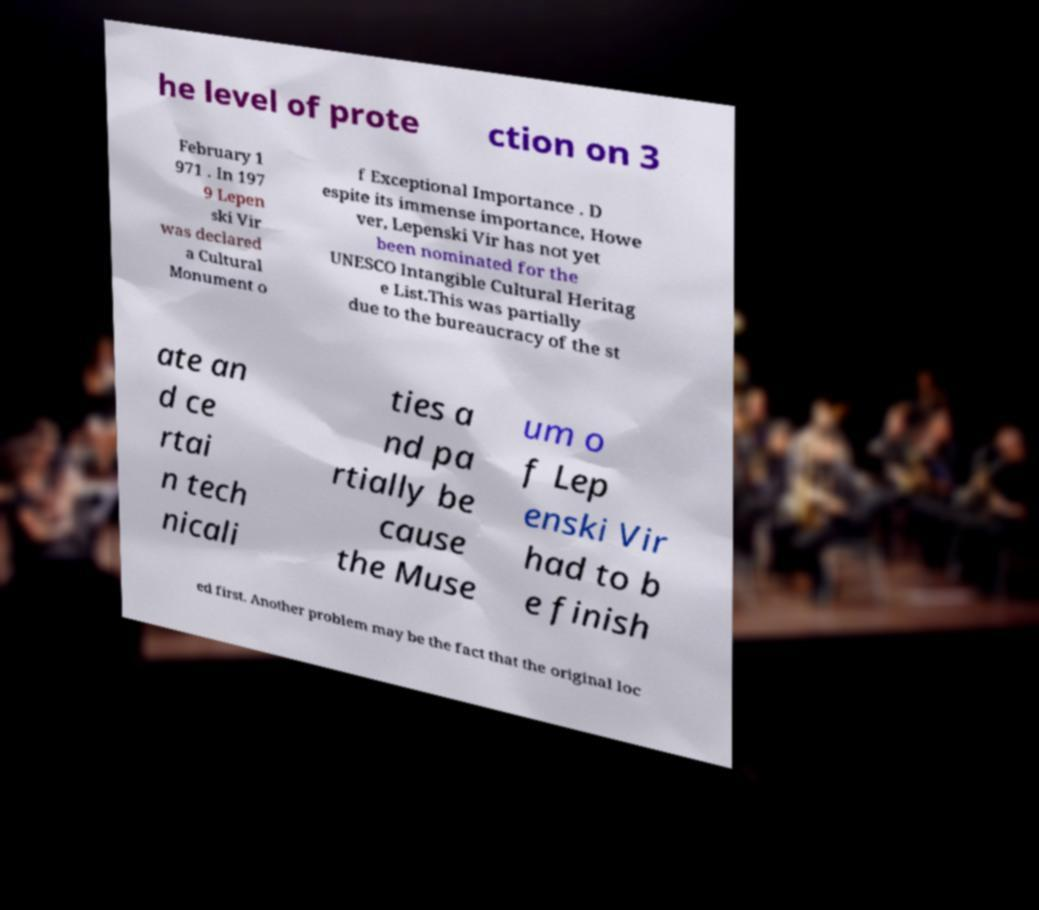What messages or text are displayed in this image? I need them in a readable, typed format. he level of prote ction on 3 February 1 971 . In 197 9 Lepen ski Vir was declared a Cultural Monument o f Exceptional Importance . D espite its immense importance, Howe ver, Lepenski Vir has not yet been nominated for the UNESCO Intangible Cultural Heritag e List.This was partially due to the bureaucracy of the st ate an d ce rtai n tech nicali ties a nd pa rtially be cause the Muse um o f Lep enski Vir had to b e finish ed first. Another problem may be the fact that the original loc 